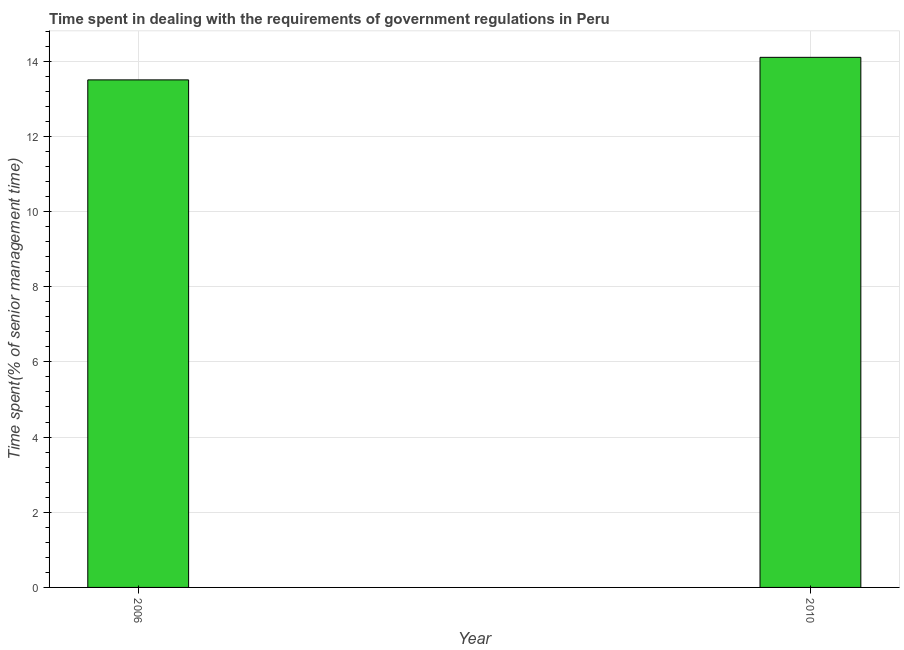Does the graph contain any zero values?
Your answer should be compact. No. What is the title of the graph?
Your response must be concise. Time spent in dealing with the requirements of government regulations in Peru. What is the label or title of the X-axis?
Ensure brevity in your answer.  Year. What is the label or title of the Y-axis?
Your answer should be very brief. Time spent(% of senior management time). What is the time spent in dealing with government regulations in 2006?
Offer a very short reply. 13.5. Across all years, what is the maximum time spent in dealing with government regulations?
Offer a very short reply. 14.1. In which year was the time spent in dealing with government regulations minimum?
Keep it short and to the point. 2006. What is the sum of the time spent in dealing with government regulations?
Ensure brevity in your answer.  27.6. Is the time spent in dealing with government regulations in 2006 less than that in 2010?
Your response must be concise. Yes. Are all the bars in the graph horizontal?
Give a very brief answer. No. How many years are there in the graph?
Make the answer very short. 2. Are the values on the major ticks of Y-axis written in scientific E-notation?
Provide a succinct answer. No. What is the Time spent(% of senior management time) in 2010?
Give a very brief answer. 14.1. What is the difference between the Time spent(% of senior management time) in 2006 and 2010?
Offer a terse response. -0.6. What is the ratio of the Time spent(% of senior management time) in 2006 to that in 2010?
Your answer should be very brief. 0.96. 